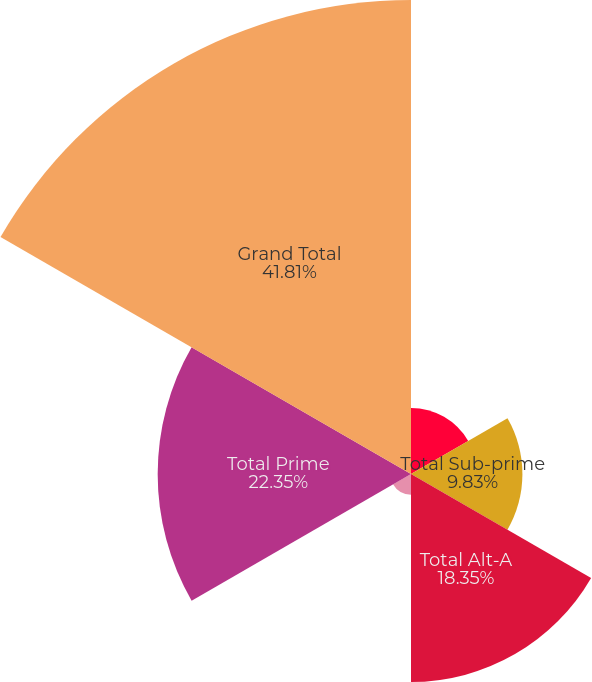Convert chart. <chart><loc_0><loc_0><loc_500><loc_500><pie_chart><fcel>Original securitizations<fcel>Total Sub-prime<fcel>Total Alt-A<fcel>Re-Remic (1)<fcel>Total Prime<fcel>Grand Total<nl><fcel>5.83%<fcel>9.83%<fcel>18.35%<fcel>1.83%<fcel>22.35%<fcel>41.82%<nl></chart> 